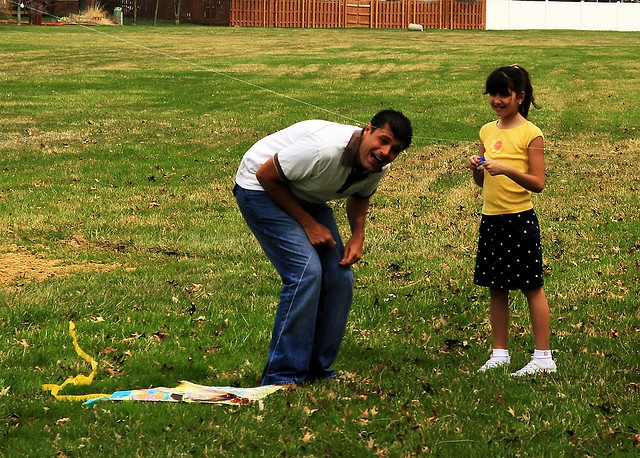Describe the objects in this image and their specific colors. I can see people in olive, black, white, darkgreen, and navy tones, people in olive, black, brown, maroon, and gold tones, and kite in olive, beige, khaki, and black tones in this image. 